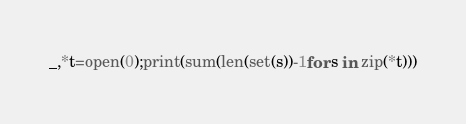Convert code to text. <code><loc_0><loc_0><loc_500><loc_500><_Python_>_,*t=open(0);print(sum(len(set(s))-1for s in zip(*t)))</code> 